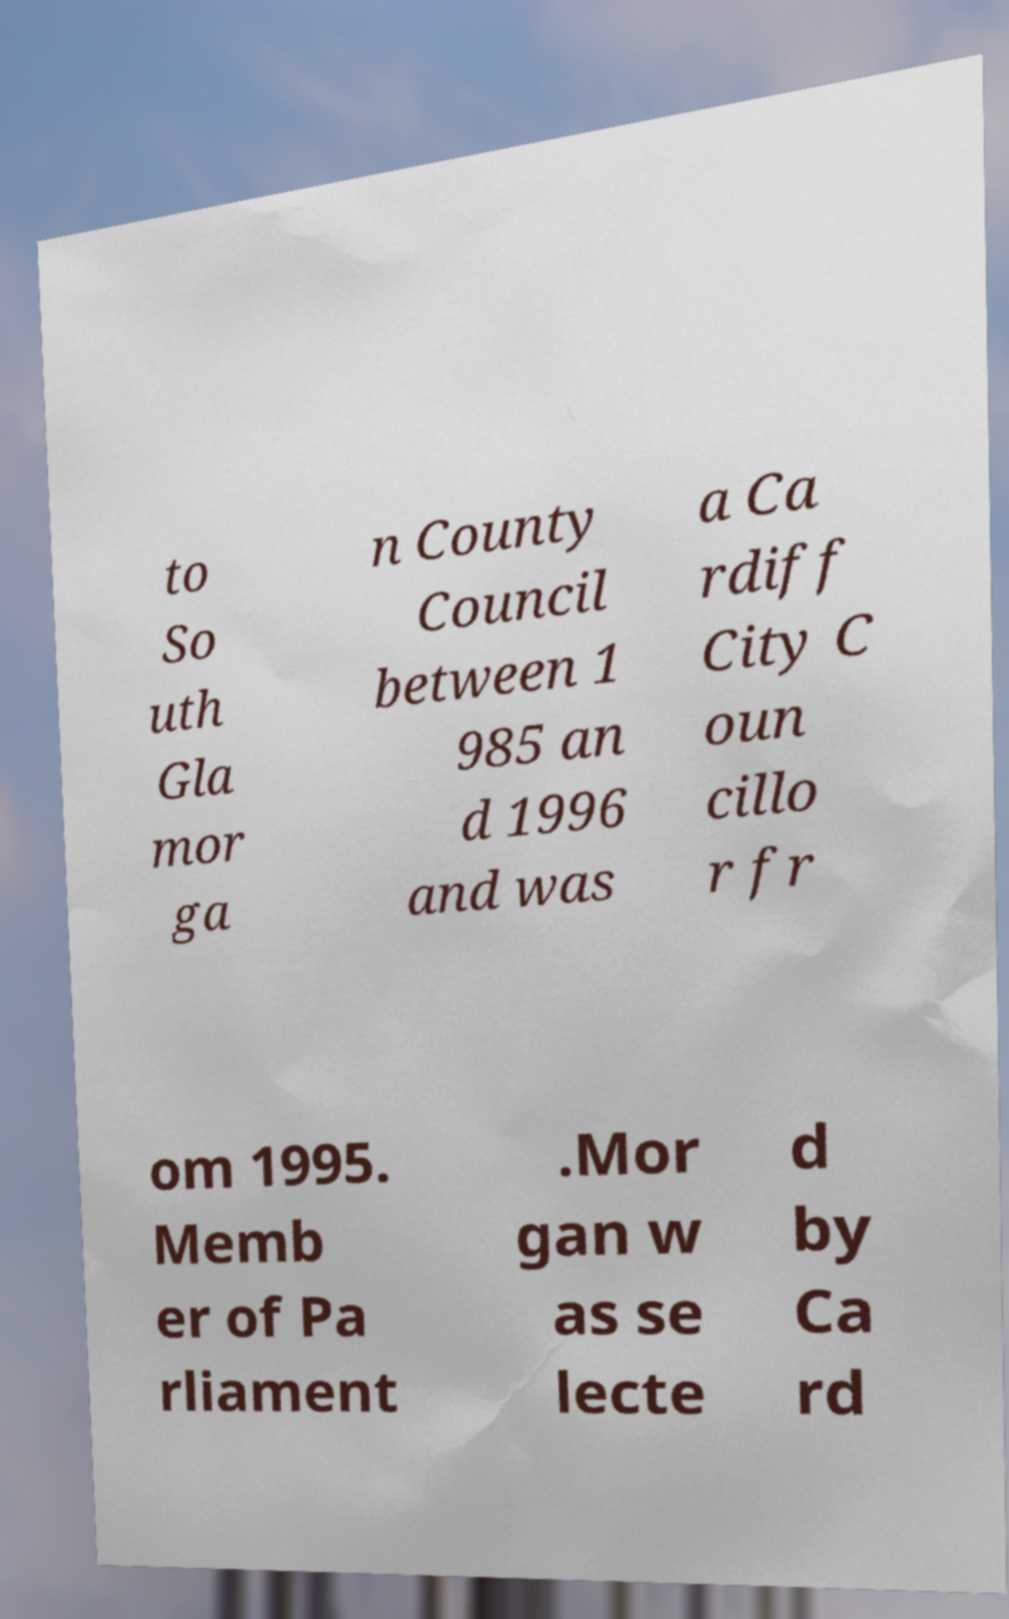What messages or text are displayed in this image? I need them in a readable, typed format. to So uth Gla mor ga n County Council between 1 985 an d 1996 and was a Ca rdiff City C oun cillo r fr om 1995. Memb er of Pa rliament .Mor gan w as se lecte d by Ca rd 